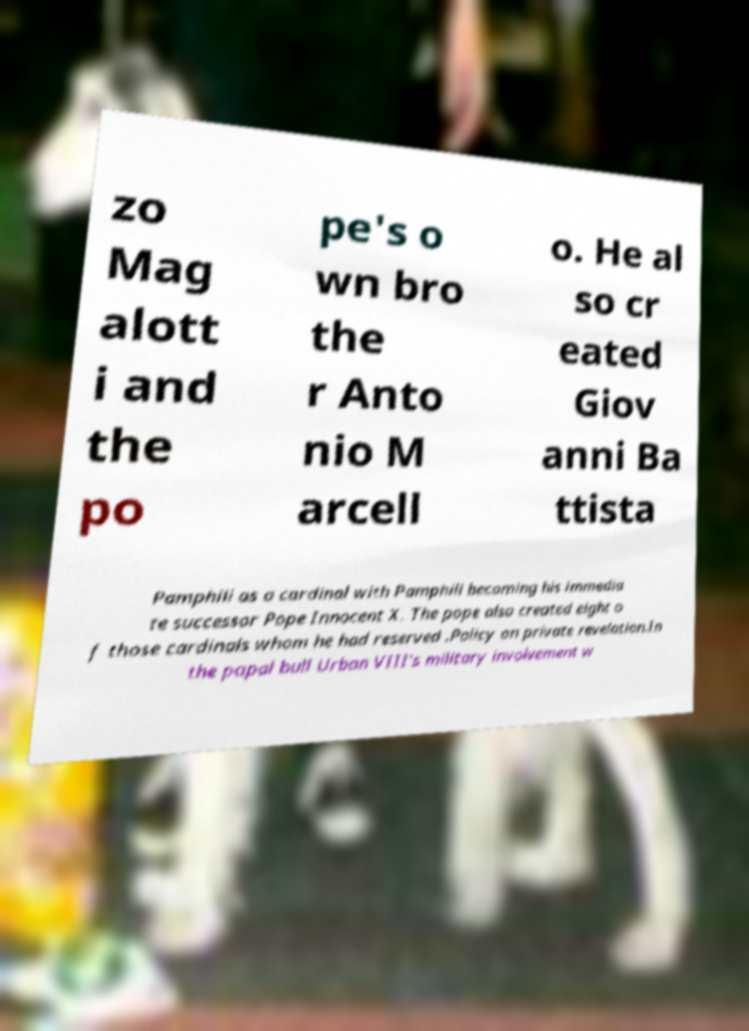Please identify and transcribe the text found in this image. zo Mag alott i and the po pe's o wn bro the r Anto nio M arcell o. He al so cr eated Giov anni Ba ttista Pamphili as a cardinal with Pamphili becoming his immedia te successor Pope Innocent X. The pope also created eight o f those cardinals whom he had reserved .Policy on private revelation.In the papal bull Urban VIII's military involvement w 